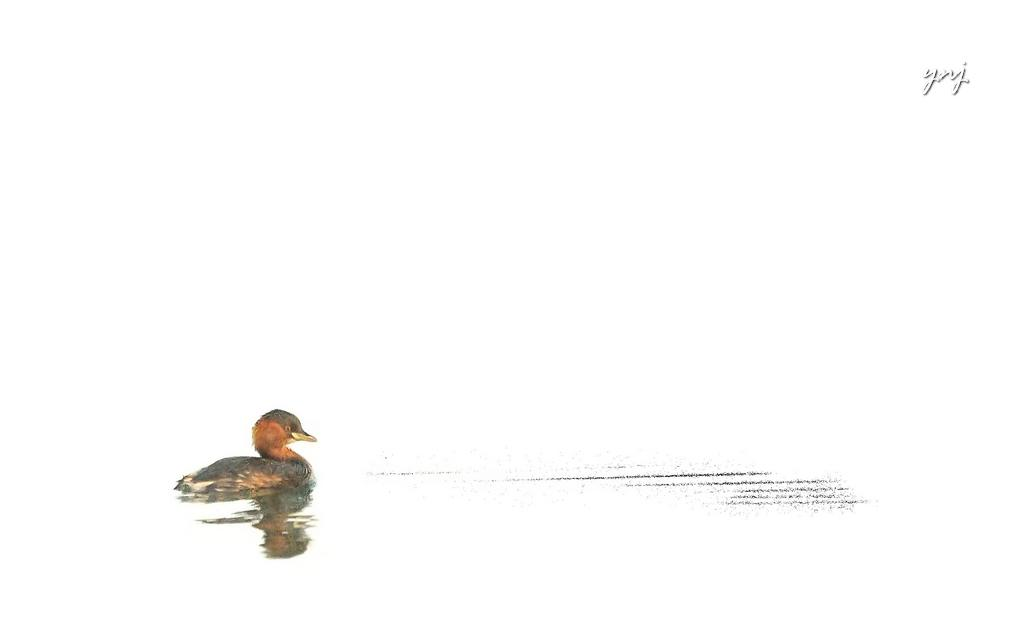What is depicted on the left side of the image? There is a sketch of a duck on the left side of the image. Where is the text located in the image? The text is in the top right side of the image. What color is the background of the image? The background of the image is white. How many wings does the honey have in the image? There is no honey present in the image, and therefore no wings can be attributed to it. 